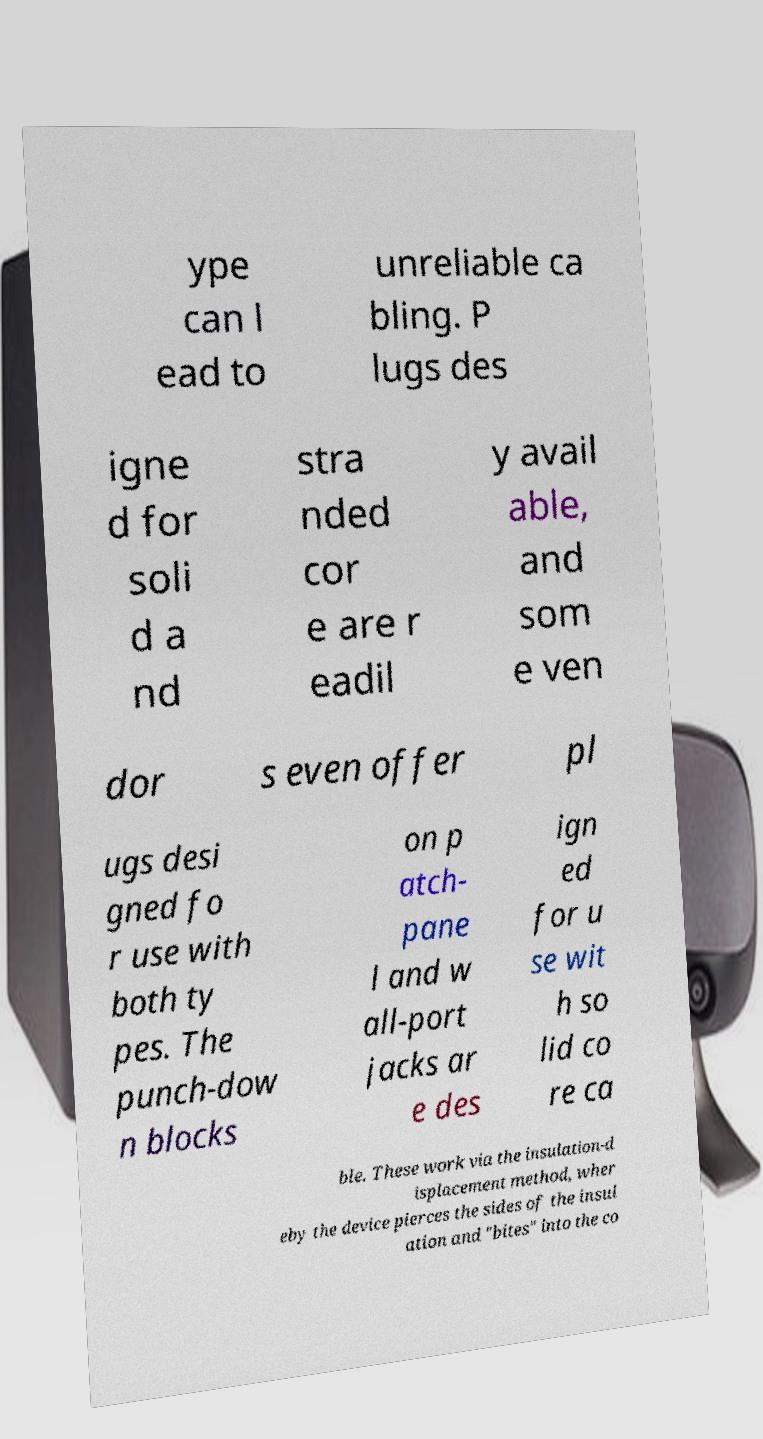Could you assist in decoding the text presented in this image and type it out clearly? ype can l ead to unreliable ca bling. P lugs des igne d for soli d a nd stra nded cor e are r eadil y avail able, and som e ven dor s even offer pl ugs desi gned fo r use with both ty pes. The punch-dow n blocks on p atch- pane l and w all-port jacks ar e des ign ed for u se wit h so lid co re ca ble. These work via the insulation-d isplacement method, wher eby the device pierces the sides of the insul ation and "bites" into the co 